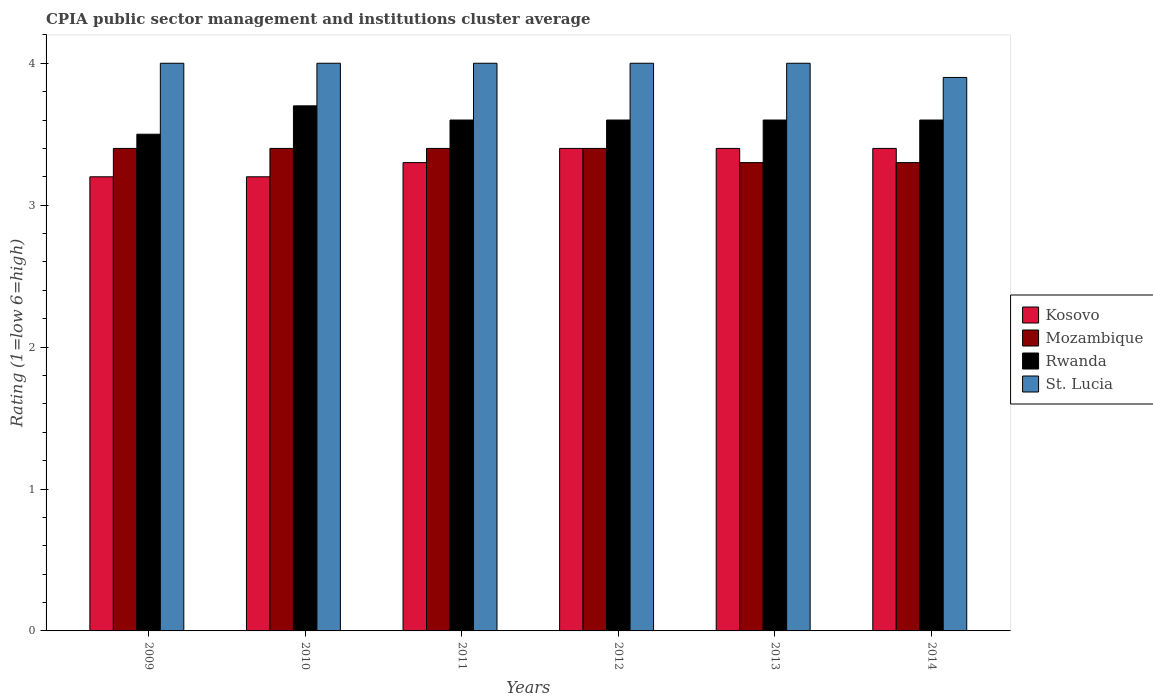How many different coloured bars are there?
Keep it short and to the point. 4. Are the number of bars on each tick of the X-axis equal?
Provide a short and direct response. Yes. How many bars are there on the 2nd tick from the left?
Provide a succinct answer. 4. What is the CPIA rating in Mozambique in 2012?
Your response must be concise. 3.4. Across all years, what is the minimum CPIA rating in Rwanda?
Your response must be concise. 3.5. What is the total CPIA rating in Rwanda in the graph?
Offer a terse response. 21.6. What is the difference between the CPIA rating in St. Lucia in 2012 and that in 2014?
Provide a succinct answer. 0.1. What is the difference between the CPIA rating in St. Lucia in 2011 and the CPIA rating in Mozambique in 2012?
Make the answer very short. 0.6. What is the average CPIA rating in Mozambique per year?
Make the answer very short. 3.37. What is the ratio of the CPIA rating in Rwanda in 2010 to that in 2011?
Your answer should be compact. 1.03. What is the difference between the highest and the second highest CPIA rating in Mozambique?
Give a very brief answer. 0. What is the difference between the highest and the lowest CPIA rating in Mozambique?
Offer a very short reply. 0.1. Is it the case that in every year, the sum of the CPIA rating in Rwanda and CPIA rating in Kosovo is greater than the sum of CPIA rating in St. Lucia and CPIA rating in Mozambique?
Provide a succinct answer. Yes. What does the 1st bar from the left in 2014 represents?
Provide a succinct answer. Kosovo. What does the 3rd bar from the right in 2011 represents?
Ensure brevity in your answer.  Mozambique. How many bars are there?
Offer a terse response. 24. How many years are there in the graph?
Provide a short and direct response. 6. How are the legend labels stacked?
Give a very brief answer. Vertical. What is the title of the graph?
Your response must be concise. CPIA public sector management and institutions cluster average. Does "Turks and Caicos Islands" appear as one of the legend labels in the graph?
Provide a succinct answer. No. What is the label or title of the X-axis?
Your answer should be very brief. Years. What is the Rating (1=low 6=high) in Mozambique in 2009?
Ensure brevity in your answer.  3.4. What is the Rating (1=low 6=high) of Rwanda in 2009?
Offer a terse response. 3.5. What is the Rating (1=low 6=high) in Kosovo in 2010?
Your response must be concise. 3.2. What is the Rating (1=low 6=high) in Rwanda in 2010?
Provide a short and direct response. 3.7. What is the Rating (1=low 6=high) of Mozambique in 2012?
Make the answer very short. 3.4. What is the Rating (1=low 6=high) in Rwanda in 2012?
Keep it short and to the point. 3.6. What is the Rating (1=low 6=high) in St. Lucia in 2012?
Make the answer very short. 4. What is the Rating (1=low 6=high) of Rwanda in 2013?
Offer a terse response. 3.6. What is the Rating (1=low 6=high) in Kosovo in 2014?
Provide a succinct answer. 3.4. What is the Rating (1=low 6=high) of Rwanda in 2014?
Your answer should be compact. 3.6. Across all years, what is the maximum Rating (1=low 6=high) of Mozambique?
Give a very brief answer. 3.4. Across all years, what is the maximum Rating (1=low 6=high) in Rwanda?
Offer a terse response. 3.7. Across all years, what is the maximum Rating (1=low 6=high) of St. Lucia?
Ensure brevity in your answer.  4. Across all years, what is the minimum Rating (1=low 6=high) in Mozambique?
Your response must be concise. 3.3. What is the total Rating (1=low 6=high) of Kosovo in the graph?
Offer a very short reply. 19.9. What is the total Rating (1=low 6=high) in Mozambique in the graph?
Keep it short and to the point. 20.2. What is the total Rating (1=low 6=high) of Rwanda in the graph?
Offer a terse response. 21.6. What is the total Rating (1=low 6=high) in St. Lucia in the graph?
Your answer should be very brief. 23.9. What is the difference between the Rating (1=low 6=high) of Rwanda in 2009 and that in 2010?
Provide a short and direct response. -0.2. What is the difference between the Rating (1=low 6=high) of Kosovo in 2009 and that in 2011?
Provide a short and direct response. -0.1. What is the difference between the Rating (1=low 6=high) of Mozambique in 2009 and that in 2011?
Ensure brevity in your answer.  0. What is the difference between the Rating (1=low 6=high) in Rwanda in 2009 and that in 2011?
Your response must be concise. -0.1. What is the difference between the Rating (1=low 6=high) of Kosovo in 2009 and that in 2012?
Make the answer very short. -0.2. What is the difference between the Rating (1=low 6=high) in Mozambique in 2009 and that in 2012?
Make the answer very short. 0. What is the difference between the Rating (1=low 6=high) in Mozambique in 2009 and that in 2013?
Ensure brevity in your answer.  0.1. What is the difference between the Rating (1=low 6=high) in Rwanda in 2009 and that in 2013?
Keep it short and to the point. -0.1. What is the difference between the Rating (1=low 6=high) in St. Lucia in 2009 and that in 2013?
Give a very brief answer. 0. What is the difference between the Rating (1=low 6=high) of Kosovo in 2009 and that in 2014?
Make the answer very short. -0.2. What is the difference between the Rating (1=low 6=high) of Mozambique in 2009 and that in 2014?
Make the answer very short. 0.1. What is the difference between the Rating (1=low 6=high) of St. Lucia in 2009 and that in 2014?
Your response must be concise. 0.1. What is the difference between the Rating (1=low 6=high) in Rwanda in 2010 and that in 2012?
Make the answer very short. 0.1. What is the difference between the Rating (1=low 6=high) in Kosovo in 2010 and that in 2013?
Your answer should be compact. -0.2. What is the difference between the Rating (1=low 6=high) in Mozambique in 2010 and that in 2013?
Your response must be concise. 0.1. What is the difference between the Rating (1=low 6=high) in St. Lucia in 2010 and that in 2013?
Your answer should be compact. 0. What is the difference between the Rating (1=low 6=high) in Kosovo in 2010 and that in 2014?
Offer a very short reply. -0.2. What is the difference between the Rating (1=low 6=high) in Rwanda in 2010 and that in 2014?
Ensure brevity in your answer.  0.1. What is the difference between the Rating (1=low 6=high) of Rwanda in 2011 and that in 2012?
Offer a terse response. 0. What is the difference between the Rating (1=low 6=high) in Kosovo in 2011 and that in 2013?
Provide a short and direct response. -0.1. What is the difference between the Rating (1=low 6=high) of Mozambique in 2011 and that in 2013?
Provide a succinct answer. 0.1. What is the difference between the Rating (1=low 6=high) of Rwanda in 2011 and that in 2013?
Your answer should be very brief. 0. What is the difference between the Rating (1=low 6=high) in St. Lucia in 2011 and that in 2013?
Provide a short and direct response. 0. What is the difference between the Rating (1=low 6=high) in Kosovo in 2011 and that in 2014?
Offer a terse response. -0.1. What is the difference between the Rating (1=low 6=high) of Rwanda in 2011 and that in 2014?
Provide a succinct answer. 0. What is the difference between the Rating (1=low 6=high) in St. Lucia in 2011 and that in 2014?
Ensure brevity in your answer.  0.1. What is the difference between the Rating (1=low 6=high) of Kosovo in 2012 and that in 2013?
Offer a terse response. 0. What is the difference between the Rating (1=low 6=high) in Mozambique in 2012 and that in 2013?
Make the answer very short. 0.1. What is the difference between the Rating (1=low 6=high) in Rwanda in 2012 and that in 2013?
Provide a succinct answer. 0. What is the difference between the Rating (1=low 6=high) of Kosovo in 2012 and that in 2014?
Provide a succinct answer. 0. What is the difference between the Rating (1=low 6=high) of Rwanda in 2012 and that in 2014?
Your response must be concise. 0. What is the difference between the Rating (1=low 6=high) of Mozambique in 2013 and that in 2014?
Your answer should be compact. 0. What is the difference between the Rating (1=low 6=high) of Rwanda in 2013 and that in 2014?
Make the answer very short. 0. What is the difference between the Rating (1=low 6=high) in Kosovo in 2009 and the Rating (1=low 6=high) in Mozambique in 2010?
Provide a succinct answer. -0.2. What is the difference between the Rating (1=low 6=high) in Kosovo in 2009 and the Rating (1=low 6=high) in Rwanda in 2010?
Your response must be concise. -0.5. What is the difference between the Rating (1=low 6=high) in Kosovo in 2009 and the Rating (1=low 6=high) in St. Lucia in 2010?
Make the answer very short. -0.8. What is the difference between the Rating (1=low 6=high) in Rwanda in 2009 and the Rating (1=low 6=high) in St. Lucia in 2010?
Your response must be concise. -0.5. What is the difference between the Rating (1=low 6=high) in Kosovo in 2009 and the Rating (1=low 6=high) in Mozambique in 2011?
Ensure brevity in your answer.  -0.2. What is the difference between the Rating (1=low 6=high) of Kosovo in 2009 and the Rating (1=low 6=high) of Rwanda in 2011?
Your answer should be very brief. -0.4. What is the difference between the Rating (1=low 6=high) in Kosovo in 2009 and the Rating (1=low 6=high) in Mozambique in 2012?
Your answer should be very brief. -0.2. What is the difference between the Rating (1=low 6=high) in Kosovo in 2009 and the Rating (1=low 6=high) in Rwanda in 2012?
Offer a very short reply. -0.4. What is the difference between the Rating (1=low 6=high) in Mozambique in 2009 and the Rating (1=low 6=high) in St. Lucia in 2012?
Keep it short and to the point. -0.6. What is the difference between the Rating (1=low 6=high) of Rwanda in 2009 and the Rating (1=low 6=high) of St. Lucia in 2012?
Provide a succinct answer. -0.5. What is the difference between the Rating (1=low 6=high) of Kosovo in 2009 and the Rating (1=low 6=high) of Mozambique in 2013?
Provide a short and direct response. -0.1. What is the difference between the Rating (1=low 6=high) in Kosovo in 2009 and the Rating (1=low 6=high) in St. Lucia in 2013?
Offer a very short reply. -0.8. What is the difference between the Rating (1=low 6=high) of Mozambique in 2009 and the Rating (1=low 6=high) of St. Lucia in 2013?
Make the answer very short. -0.6. What is the difference between the Rating (1=low 6=high) of Rwanda in 2009 and the Rating (1=low 6=high) of St. Lucia in 2013?
Provide a succinct answer. -0.5. What is the difference between the Rating (1=low 6=high) in Kosovo in 2009 and the Rating (1=low 6=high) in Rwanda in 2014?
Ensure brevity in your answer.  -0.4. What is the difference between the Rating (1=low 6=high) in Kosovo in 2009 and the Rating (1=low 6=high) in St. Lucia in 2014?
Give a very brief answer. -0.7. What is the difference between the Rating (1=low 6=high) of Mozambique in 2009 and the Rating (1=low 6=high) of Rwanda in 2014?
Ensure brevity in your answer.  -0.2. What is the difference between the Rating (1=low 6=high) of Mozambique in 2009 and the Rating (1=low 6=high) of St. Lucia in 2014?
Provide a succinct answer. -0.5. What is the difference between the Rating (1=low 6=high) of Kosovo in 2010 and the Rating (1=low 6=high) of Mozambique in 2011?
Ensure brevity in your answer.  -0.2. What is the difference between the Rating (1=low 6=high) of Kosovo in 2010 and the Rating (1=low 6=high) of Rwanda in 2011?
Your response must be concise. -0.4. What is the difference between the Rating (1=low 6=high) of Mozambique in 2010 and the Rating (1=low 6=high) of Rwanda in 2011?
Offer a terse response. -0.2. What is the difference between the Rating (1=low 6=high) of Rwanda in 2010 and the Rating (1=low 6=high) of St. Lucia in 2011?
Your response must be concise. -0.3. What is the difference between the Rating (1=low 6=high) in Kosovo in 2010 and the Rating (1=low 6=high) in Mozambique in 2012?
Make the answer very short. -0.2. What is the difference between the Rating (1=low 6=high) of Rwanda in 2010 and the Rating (1=low 6=high) of St. Lucia in 2012?
Provide a succinct answer. -0.3. What is the difference between the Rating (1=low 6=high) of Kosovo in 2010 and the Rating (1=low 6=high) of Rwanda in 2013?
Offer a very short reply. -0.4. What is the difference between the Rating (1=low 6=high) of Kosovo in 2010 and the Rating (1=low 6=high) of St. Lucia in 2013?
Provide a succinct answer. -0.8. What is the difference between the Rating (1=low 6=high) in Mozambique in 2010 and the Rating (1=low 6=high) in Rwanda in 2013?
Offer a terse response. -0.2. What is the difference between the Rating (1=low 6=high) of Kosovo in 2010 and the Rating (1=low 6=high) of Rwanda in 2014?
Offer a very short reply. -0.4. What is the difference between the Rating (1=low 6=high) of Kosovo in 2010 and the Rating (1=low 6=high) of St. Lucia in 2014?
Give a very brief answer. -0.7. What is the difference between the Rating (1=low 6=high) in Mozambique in 2010 and the Rating (1=low 6=high) in Rwanda in 2014?
Offer a terse response. -0.2. What is the difference between the Rating (1=low 6=high) of Mozambique in 2011 and the Rating (1=low 6=high) of St. Lucia in 2012?
Provide a succinct answer. -0.6. What is the difference between the Rating (1=low 6=high) in Kosovo in 2011 and the Rating (1=low 6=high) in Mozambique in 2013?
Provide a succinct answer. 0. What is the difference between the Rating (1=low 6=high) of Mozambique in 2011 and the Rating (1=low 6=high) of Rwanda in 2013?
Provide a short and direct response. -0.2. What is the difference between the Rating (1=low 6=high) of Mozambique in 2011 and the Rating (1=low 6=high) of St. Lucia in 2013?
Offer a terse response. -0.6. What is the difference between the Rating (1=low 6=high) of Rwanda in 2011 and the Rating (1=low 6=high) of St. Lucia in 2013?
Provide a short and direct response. -0.4. What is the difference between the Rating (1=low 6=high) in Kosovo in 2011 and the Rating (1=low 6=high) in Mozambique in 2014?
Keep it short and to the point. 0. What is the difference between the Rating (1=low 6=high) of Kosovo in 2011 and the Rating (1=low 6=high) of Rwanda in 2014?
Your answer should be compact. -0.3. What is the difference between the Rating (1=low 6=high) in Kosovo in 2011 and the Rating (1=low 6=high) in St. Lucia in 2014?
Offer a terse response. -0.6. What is the difference between the Rating (1=low 6=high) in Mozambique in 2011 and the Rating (1=low 6=high) in Rwanda in 2014?
Offer a terse response. -0.2. What is the difference between the Rating (1=low 6=high) of Mozambique in 2011 and the Rating (1=low 6=high) of St. Lucia in 2014?
Your answer should be very brief. -0.5. What is the difference between the Rating (1=low 6=high) in Kosovo in 2012 and the Rating (1=low 6=high) in Mozambique in 2013?
Your answer should be compact. 0.1. What is the difference between the Rating (1=low 6=high) of Kosovo in 2012 and the Rating (1=low 6=high) of Rwanda in 2013?
Provide a short and direct response. -0.2. What is the difference between the Rating (1=low 6=high) in Kosovo in 2012 and the Rating (1=low 6=high) in Mozambique in 2014?
Offer a terse response. 0.1. What is the difference between the Rating (1=low 6=high) of Kosovo in 2012 and the Rating (1=low 6=high) of Rwanda in 2014?
Your answer should be compact. -0.2. What is the difference between the Rating (1=low 6=high) in Kosovo in 2012 and the Rating (1=low 6=high) in St. Lucia in 2014?
Offer a very short reply. -0.5. What is the difference between the Rating (1=low 6=high) in Mozambique in 2012 and the Rating (1=low 6=high) in Rwanda in 2014?
Provide a short and direct response. -0.2. What is the difference between the Rating (1=low 6=high) of Rwanda in 2012 and the Rating (1=low 6=high) of St. Lucia in 2014?
Offer a very short reply. -0.3. What is the difference between the Rating (1=low 6=high) in Kosovo in 2013 and the Rating (1=low 6=high) in Mozambique in 2014?
Make the answer very short. 0.1. What is the difference between the Rating (1=low 6=high) of Kosovo in 2013 and the Rating (1=low 6=high) of Rwanda in 2014?
Provide a short and direct response. -0.2. What is the difference between the Rating (1=low 6=high) of Mozambique in 2013 and the Rating (1=low 6=high) of Rwanda in 2014?
Your response must be concise. -0.3. What is the average Rating (1=low 6=high) in Kosovo per year?
Give a very brief answer. 3.32. What is the average Rating (1=low 6=high) of Mozambique per year?
Keep it short and to the point. 3.37. What is the average Rating (1=low 6=high) of Rwanda per year?
Offer a very short reply. 3.6. What is the average Rating (1=low 6=high) of St. Lucia per year?
Give a very brief answer. 3.98. In the year 2009, what is the difference between the Rating (1=low 6=high) in Kosovo and Rating (1=low 6=high) in Mozambique?
Ensure brevity in your answer.  -0.2. In the year 2009, what is the difference between the Rating (1=low 6=high) in Mozambique and Rating (1=low 6=high) in St. Lucia?
Your response must be concise. -0.6. In the year 2009, what is the difference between the Rating (1=low 6=high) of Rwanda and Rating (1=low 6=high) of St. Lucia?
Provide a succinct answer. -0.5. In the year 2010, what is the difference between the Rating (1=low 6=high) in Kosovo and Rating (1=low 6=high) in Mozambique?
Your response must be concise. -0.2. In the year 2010, what is the difference between the Rating (1=low 6=high) of Rwanda and Rating (1=low 6=high) of St. Lucia?
Provide a succinct answer. -0.3. In the year 2011, what is the difference between the Rating (1=low 6=high) of Kosovo and Rating (1=low 6=high) of Mozambique?
Ensure brevity in your answer.  -0.1. In the year 2011, what is the difference between the Rating (1=low 6=high) in Kosovo and Rating (1=low 6=high) in Rwanda?
Provide a succinct answer. -0.3. In the year 2011, what is the difference between the Rating (1=low 6=high) in Mozambique and Rating (1=low 6=high) in Rwanda?
Keep it short and to the point. -0.2. In the year 2011, what is the difference between the Rating (1=low 6=high) of Mozambique and Rating (1=low 6=high) of St. Lucia?
Your answer should be compact. -0.6. In the year 2011, what is the difference between the Rating (1=low 6=high) in Rwanda and Rating (1=low 6=high) in St. Lucia?
Offer a very short reply. -0.4. In the year 2012, what is the difference between the Rating (1=low 6=high) in Kosovo and Rating (1=low 6=high) in St. Lucia?
Keep it short and to the point. -0.6. In the year 2012, what is the difference between the Rating (1=low 6=high) in Mozambique and Rating (1=low 6=high) in Rwanda?
Keep it short and to the point. -0.2. In the year 2012, what is the difference between the Rating (1=low 6=high) of Mozambique and Rating (1=low 6=high) of St. Lucia?
Provide a short and direct response. -0.6. In the year 2013, what is the difference between the Rating (1=low 6=high) of Kosovo and Rating (1=low 6=high) of Rwanda?
Your response must be concise. -0.2. In the year 2013, what is the difference between the Rating (1=low 6=high) of Kosovo and Rating (1=low 6=high) of St. Lucia?
Give a very brief answer. -0.6. In the year 2013, what is the difference between the Rating (1=low 6=high) of Mozambique and Rating (1=low 6=high) of St. Lucia?
Provide a short and direct response. -0.7. In the year 2014, what is the difference between the Rating (1=low 6=high) of Kosovo and Rating (1=low 6=high) of St. Lucia?
Give a very brief answer. -0.5. In the year 2014, what is the difference between the Rating (1=low 6=high) in Mozambique and Rating (1=low 6=high) in St. Lucia?
Make the answer very short. -0.6. What is the ratio of the Rating (1=low 6=high) of Mozambique in 2009 to that in 2010?
Provide a succinct answer. 1. What is the ratio of the Rating (1=low 6=high) of Rwanda in 2009 to that in 2010?
Your answer should be very brief. 0.95. What is the ratio of the Rating (1=low 6=high) of St. Lucia in 2009 to that in 2010?
Your answer should be compact. 1. What is the ratio of the Rating (1=low 6=high) in Kosovo in 2009 to that in 2011?
Offer a terse response. 0.97. What is the ratio of the Rating (1=low 6=high) of Rwanda in 2009 to that in 2011?
Your response must be concise. 0.97. What is the ratio of the Rating (1=low 6=high) of Mozambique in 2009 to that in 2012?
Give a very brief answer. 1. What is the ratio of the Rating (1=low 6=high) in Rwanda in 2009 to that in 2012?
Provide a succinct answer. 0.97. What is the ratio of the Rating (1=low 6=high) of Kosovo in 2009 to that in 2013?
Give a very brief answer. 0.94. What is the ratio of the Rating (1=low 6=high) of Mozambique in 2009 to that in 2013?
Offer a terse response. 1.03. What is the ratio of the Rating (1=low 6=high) in Rwanda in 2009 to that in 2013?
Offer a very short reply. 0.97. What is the ratio of the Rating (1=low 6=high) of St. Lucia in 2009 to that in 2013?
Provide a short and direct response. 1. What is the ratio of the Rating (1=low 6=high) in Kosovo in 2009 to that in 2014?
Provide a succinct answer. 0.94. What is the ratio of the Rating (1=low 6=high) in Mozambique in 2009 to that in 2014?
Offer a terse response. 1.03. What is the ratio of the Rating (1=low 6=high) in Rwanda in 2009 to that in 2014?
Keep it short and to the point. 0.97. What is the ratio of the Rating (1=low 6=high) in St. Lucia in 2009 to that in 2014?
Offer a very short reply. 1.03. What is the ratio of the Rating (1=low 6=high) of Kosovo in 2010 to that in 2011?
Offer a very short reply. 0.97. What is the ratio of the Rating (1=low 6=high) of Mozambique in 2010 to that in 2011?
Give a very brief answer. 1. What is the ratio of the Rating (1=low 6=high) in Rwanda in 2010 to that in 2011?
Provide a short and direct response. 1.03. What is the ratio of the Rating (1=low 6=high) of St. Lucia in 2010 to that in 2011?
Your answer should be very brief. 1. What is the ratio of the Rating (1=low 6=high) of Rwanda in 2010 to that in 2012?
Provide a succinct answer. 1.03. What is the ratio of the Rating (1=low 6=high) in St. Lucia in 2010 to that in 2012?
Your answer should be very brief. 1. What is the ratio of the Rating (1=low 6=high) in Mozambique in 2010 to that in 2013?
Provide a short and direct response. 1.03. What is the ratio of the Rating (1=low 6=high) in Rwanda in 2010 to that in 2013?
Give a very brief answer. 1.03. What is the ratio of the Rating (1=low 6=high) of Mozambique in 2010 to that in 2014?
Offer a very short reply. 1.03. What is the ratio of the Rating (1=low 6=high) of Rwanda in 2010 to that in 2014?
Offer a terse response. 1.03. What is the ratio of the Rating (1=low 6=high) of St. Lucia in 2010 to that in 2014?
Provide a succinct answer. 1.03. What is the ratio of the Rating (1=low 6=high) of Kosovo in 2011 to that in 2012?
Give a very brief answer. 0.97. What is the ratio of the Rating (1=low 6=high) of Mozambique in 2011 to that in 2012?
Ensure brevity in your answer.  1. What is the ratio of the Rating (1=low 6=high) of Rwanda in 2011 to that in 2012?
Your answer should be very brief. 1. What is the ratio of the Rating (1=low 6=high) of St. Lucia in 2011 to that in 2012?
Offer a very short reply. 1. What is the ratio of the Rating (1=low 6=high) in Kosovo in 2011 to that in 2013?
Give a very brief answer. 0.97. What is the ratio of the Rating (1=low 6=high) of Mozambique in 2011 to that in 2013?
Keep it short and to the point. 1.03. What is the ratio of the Rating (1=low 6=high) of Kosovo in 2011 to that in 2014?
Your response must be concise. 0.97. What is the ratio of the Rating (1=low 6=high) in Mozambique in 2011 to that in 2014?
Your response must be concise. 1.03. What is the ratio of the Rating (1=low 6=high) of St. Lucia in 2011 to that in 2014?
Offer a very short reply. 1.03. What is the ratio of the Rating (1=low 6=high) of Kosovo in 2012 to that in 2013?
Provide a succinct answer. 1. What is the ratio of the Rating (1=low 6=high) in Mozambique in 2012 to that in 2013?
Your answer should be compact. 1.03. What is the ratio of the Rating (1=low 6=high) of St. Lucia in 2012 to that in 2013?
Offer a terse response. 1. What is the ratio of the Rating (1=low 6=high) in Kosovo in 2012 to that in 2014?
Your answer should be very brief. 1. What is the ratio of the Rating (1=low 6=high) of Mozambique in 2012 to that in 2014?
Your response must be concise. 1.03. What is the ratio of the Rating (1=low 6=high) in St. Lucia in 2012 to that in 2014?
Provide a succinct answer. 1.03. What is the ratio of the Rating (1=low 6=high) of Kosovo in 2013 to that in 2014?
Your answer should be very brief. 1. What is the ratio of the Rating (1=low 6=high) of Mozambique in 2013 to that in 2014?
Offer a terse response. 1. What is the ratio of the Rating (1=low 6=high) in St. Lucia in 2013 to that in 2014?
Your answer should be compact. 1.03. What is the difference between the highest and the second highest Rating (1=low 6=high) in Mozambique?
Make the answer very short. 0. What is the difference between the highest and the second highest Rating (1=low 6=high) in St. Lucia?
Your response must be concise. 0. What is the difference between the highest and the lowest Rating (1=low 6=high) of Kosovo?
Provide a succinct answer. 0.2. What is the difference between the highest and the lowest Rating (1=low 6=high) in Rwanda?
Ensure brevity in your answer.  0.2. 